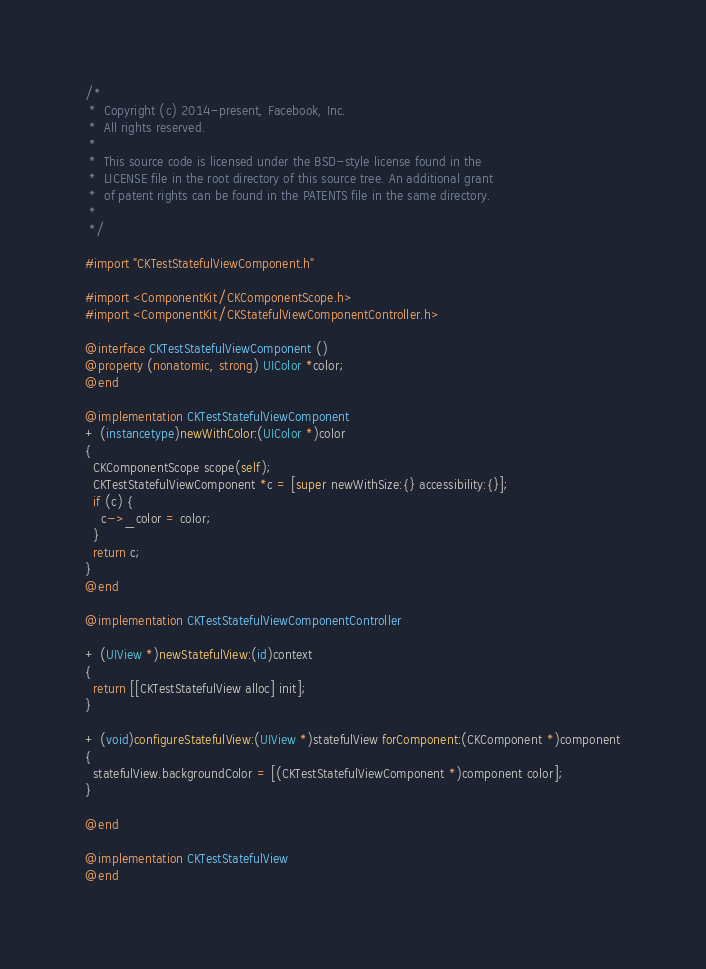Convert code to text. <code><loc_0><loc_0><loc_500><loc_500><_ObjectiveC_>/*
 *  Copyright (c) 2014-present, Facebook, Inc.
 *  All rights reserved.
 *
 *  This source code is licensed under the BSD-style license found in the
 *  LICENSE file in the root directory of this source tree. An additional grant
 *  of patent rights can be found in the PATENTS file in the same directory.
 *
 */

#import "CKTestStatefulViewComponent.h"

#import <ComponentKit/CKComponentScope.h>
#import <ComponentKit/CKStatefulViewComponentController.h>

@interface CKTestStatefulViewComponent ()
@property (nonatomic, strong) UIColor *color;
@end

@implementation CKTestStatefulViewComponent
+ (instancetype)newWithColor:(UIColor *)color
{
  CKComponentScope scope(self);
  CKTestStatefulViewComponent *c = [super newWithSize:{} accessibility:{}];
  if (c) {
    c->_color = color;
  }
  return c;
}
@end

@implementation CKTestStatefulViewComponentController

+ (UIView *)newStatefulView:(id)context
{
  return [[CKTestStatefulView alloc] init];
}

+ (void)configureStatefulView:(UIView *)statefulView forComponent:(CKComponent *)component
{
  statefulView.backgroundColor = [(CKTestStatefulViewComponent *)component color];
}

@end

@implementation CKTestStatefulView
@end
</code> 